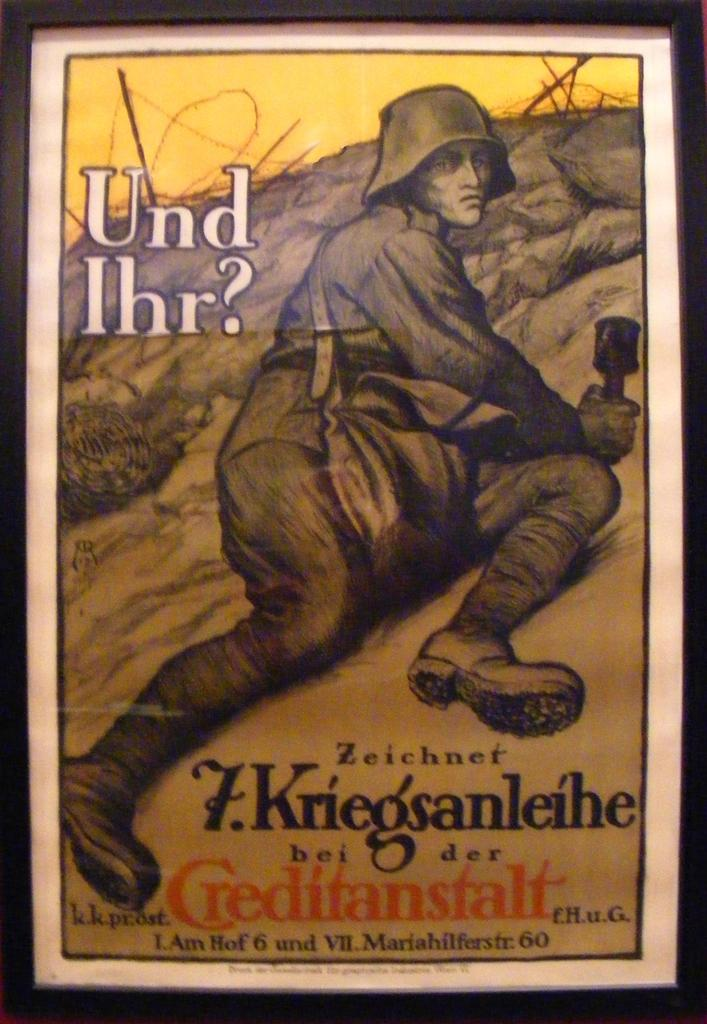Provide a one-sentence caption for the provided image. a poster with a man on it that says 'und ihr?'. 